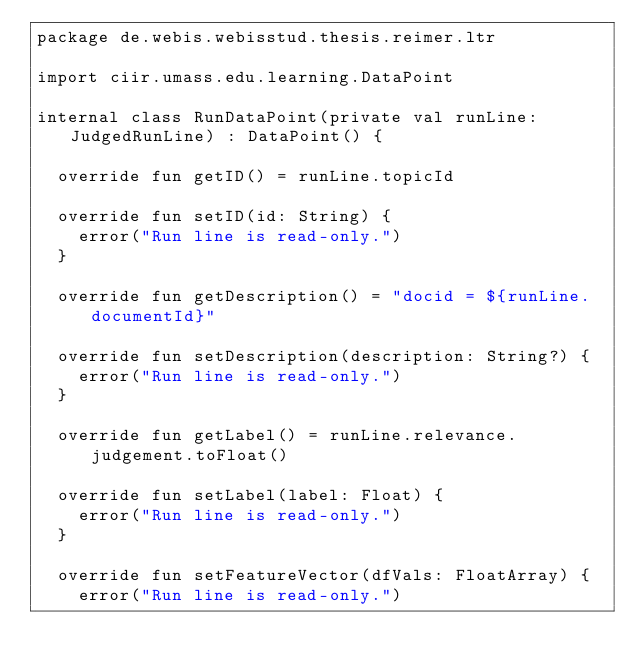<code> <loc_0><loc_0><loc_500><loc_500><_Kotlin_>package de.webis.webisstud.thesis.reimer.ltr

import ciir.umass.edu.learning.DataPoint

internal class RunDataPoint(private val runLine: JudgedRunLine) : DataPoint() {

	override fun getID() = runLine.topicId

	override fun setID(id: String) {
		error("Run line is read-only.")
	}

	override fun getDescription() = "docid = ${runLine.documentId}"

	override fun setDescription(description: String?) {
		error("Run line is read-only.")
	}

	override fun getLabel() = runLine.relevance.judgement.toFloat()

	override fun setLabel(label: Float) {
		error("Run line is read-only.")
	}

	override fun setFeatureVector(dfVals: FloatArray) {
		error("Run line is read-only.")</code> 